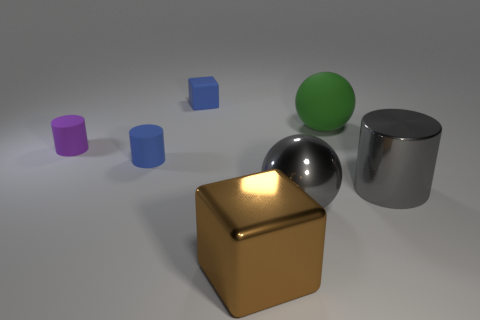Can you tell me what materials different objects in the scene appear to be made from? Certainly! In the image, we have a variety of materials depicted. The large cube in the foreground has a reflective gold surface suggesting it's made of a polished, golden material. The sphere beside it appears metallic and reflective, likely a polished chrome. The big cylinder has a similar reflective metal finish. The large green sphere looks matte, possibly a plastic or painted surface. Lastly, the smaller cylinders and cube appear to have a rubber-like matte finish, displayed in blue and purple colors. 